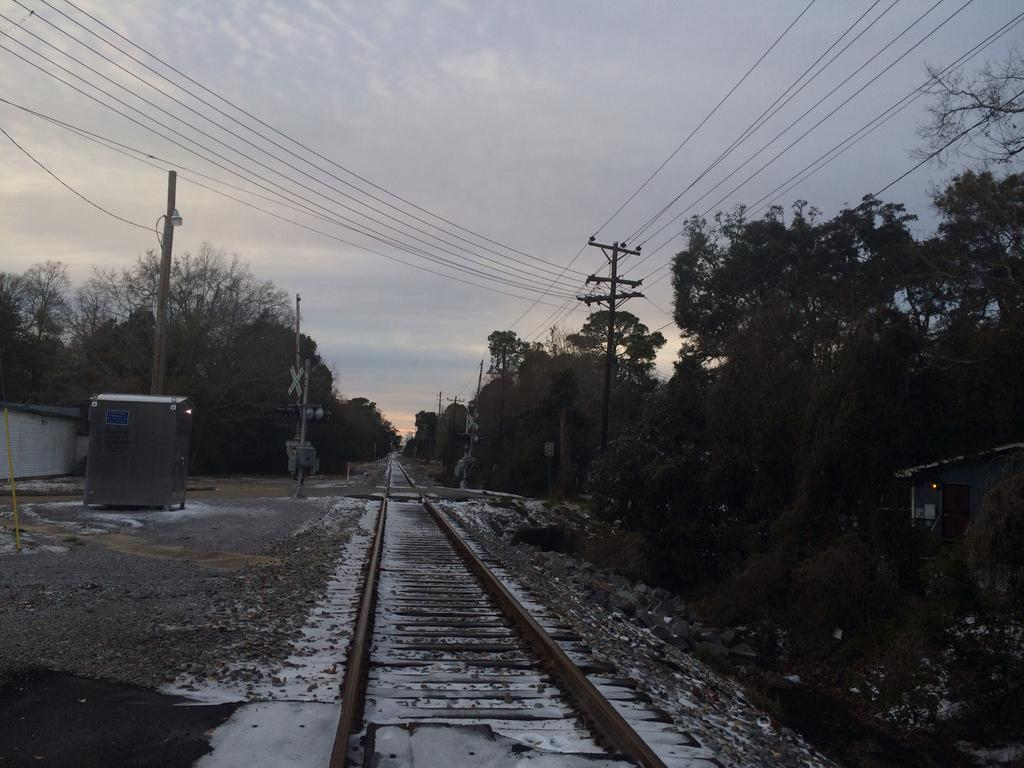What type of transportation infrastructure is visible in the image? There is a railway track in the image. What type of clothing item can be seen in the image? There are pants (likely referring to pants on a pole) in the image. What are the poles used for in the image? The poles are likely used to support the pants or other items. What is the weather like in the image? There is snow in the image, indicating a cold or wintry environment. What type of natural vegetation is visible in the image? There are trees in the image. What can be seen in the background of the image? The sky is visible in the background of the image. How does the value of the pants change throughout the image? The value of the pants does not change throughout the image, as they are stationary on the pole. What type of comfort can be found in the image? The image does not depict any specific type of comfort, as it primarily features a railway track and pants on a pole. 